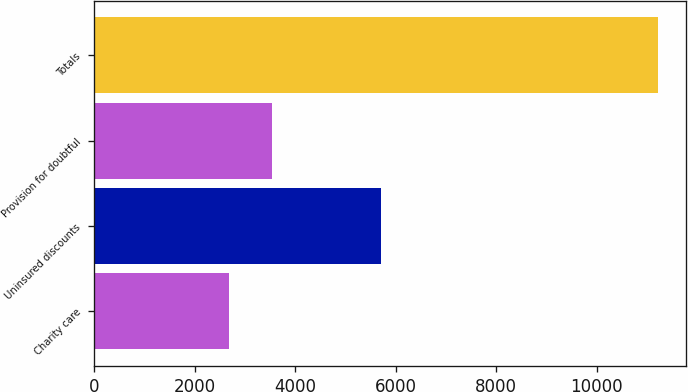Convert chart. <chart><loc_0><loc_0><loc_500><loc_500><bar_chart><fcel>Charity care<fcel>Uninsured discounts<fcel>Provision for doubtful<fcel>Totals<nl><fcel>2683<fcel>5707<fcel>3536.1<fcel>11214<nl></chart> 